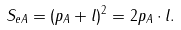<formula> <loc_0><loc_0><loc_500><loc_500>S _ { e A } = ( p _ { A } + l ) ^ { 2 } = 2 p _ { A } \cdot l .</formula> 